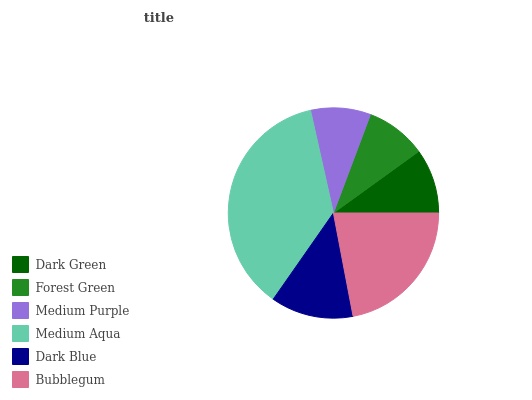Is Medium Purple the minimum?
Answer yes or no. Yes. Is Medium Aqua the maximum?
Answer yes or no. Yes. Is Forest Green the minimum?
Answer yes or no. No. Is Forest Green the maximum?
Answer yes or no. No. Is Dark Green greater than Forest Green?
Answer yes or no. Yes. Is Forest Green less than Dark Green?
Answer yes or no. Yes. Is Forest Green greater than Dark Green?
Answer yes or no. No. Is Dark Green less than Forest Green?
Answer yes or no. No. Is Dark Blue the high median?
Answer yes or no. Yes. Is Dark Green the low median?
Answer yes or no. Yes. Is Forest Green the high median?
Answer yes or no. No. Is Dark Blue the low median?
Answer yes or no. No. 